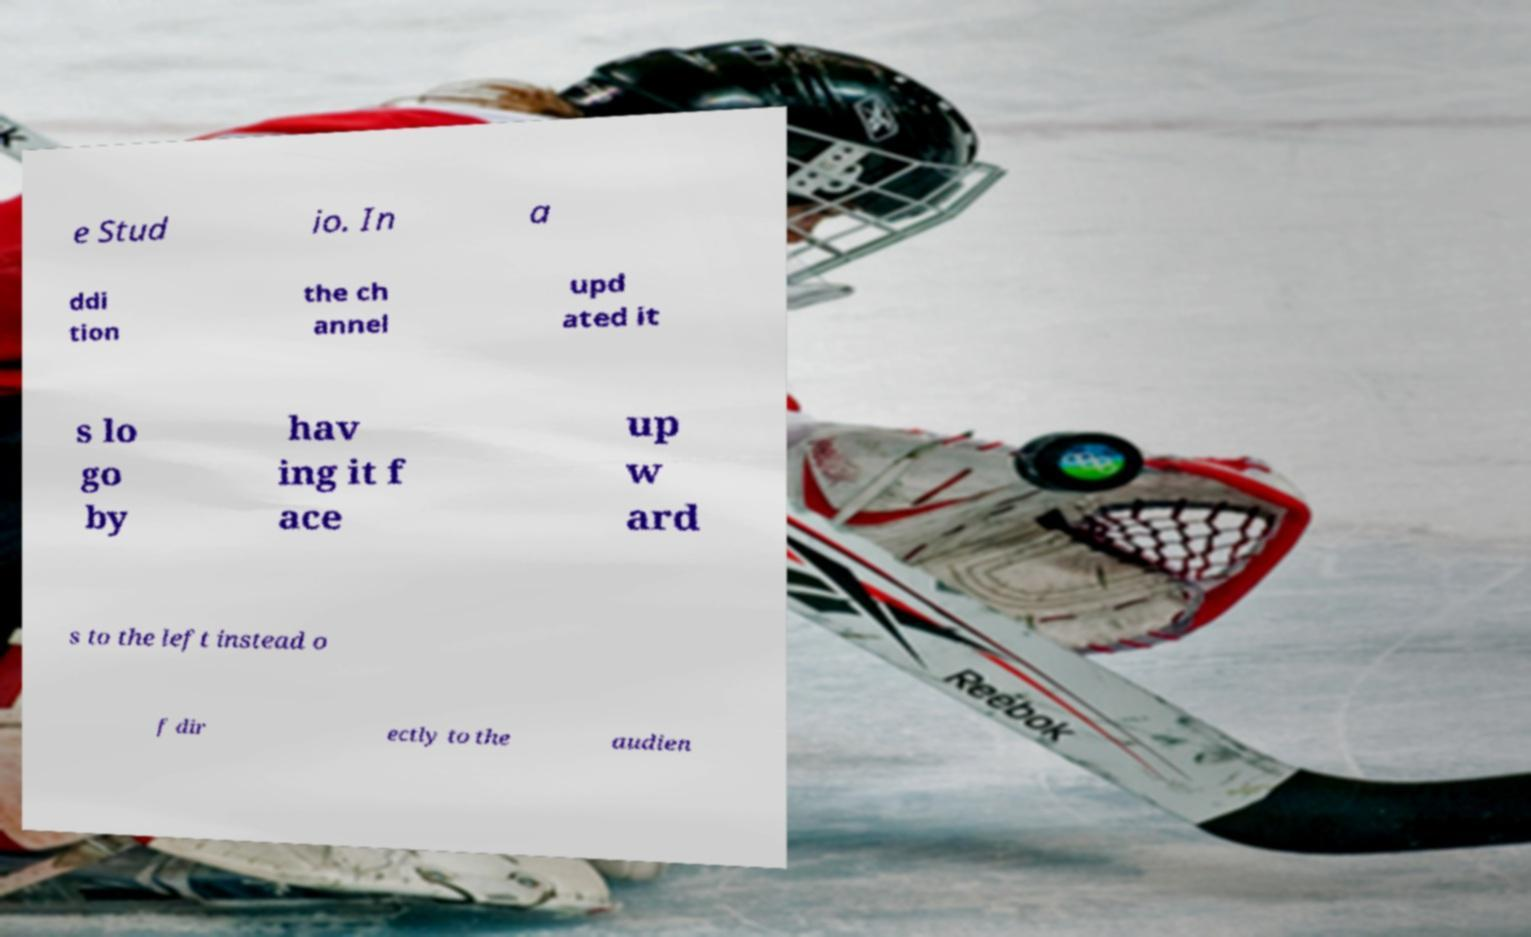Please identify and transcribe the text found in this image. e Stud io. In a ddi tion the ch annel upd ated it s lo go by hav ing it f ace up w ard s to the left instead o f dir ectly to the audien 